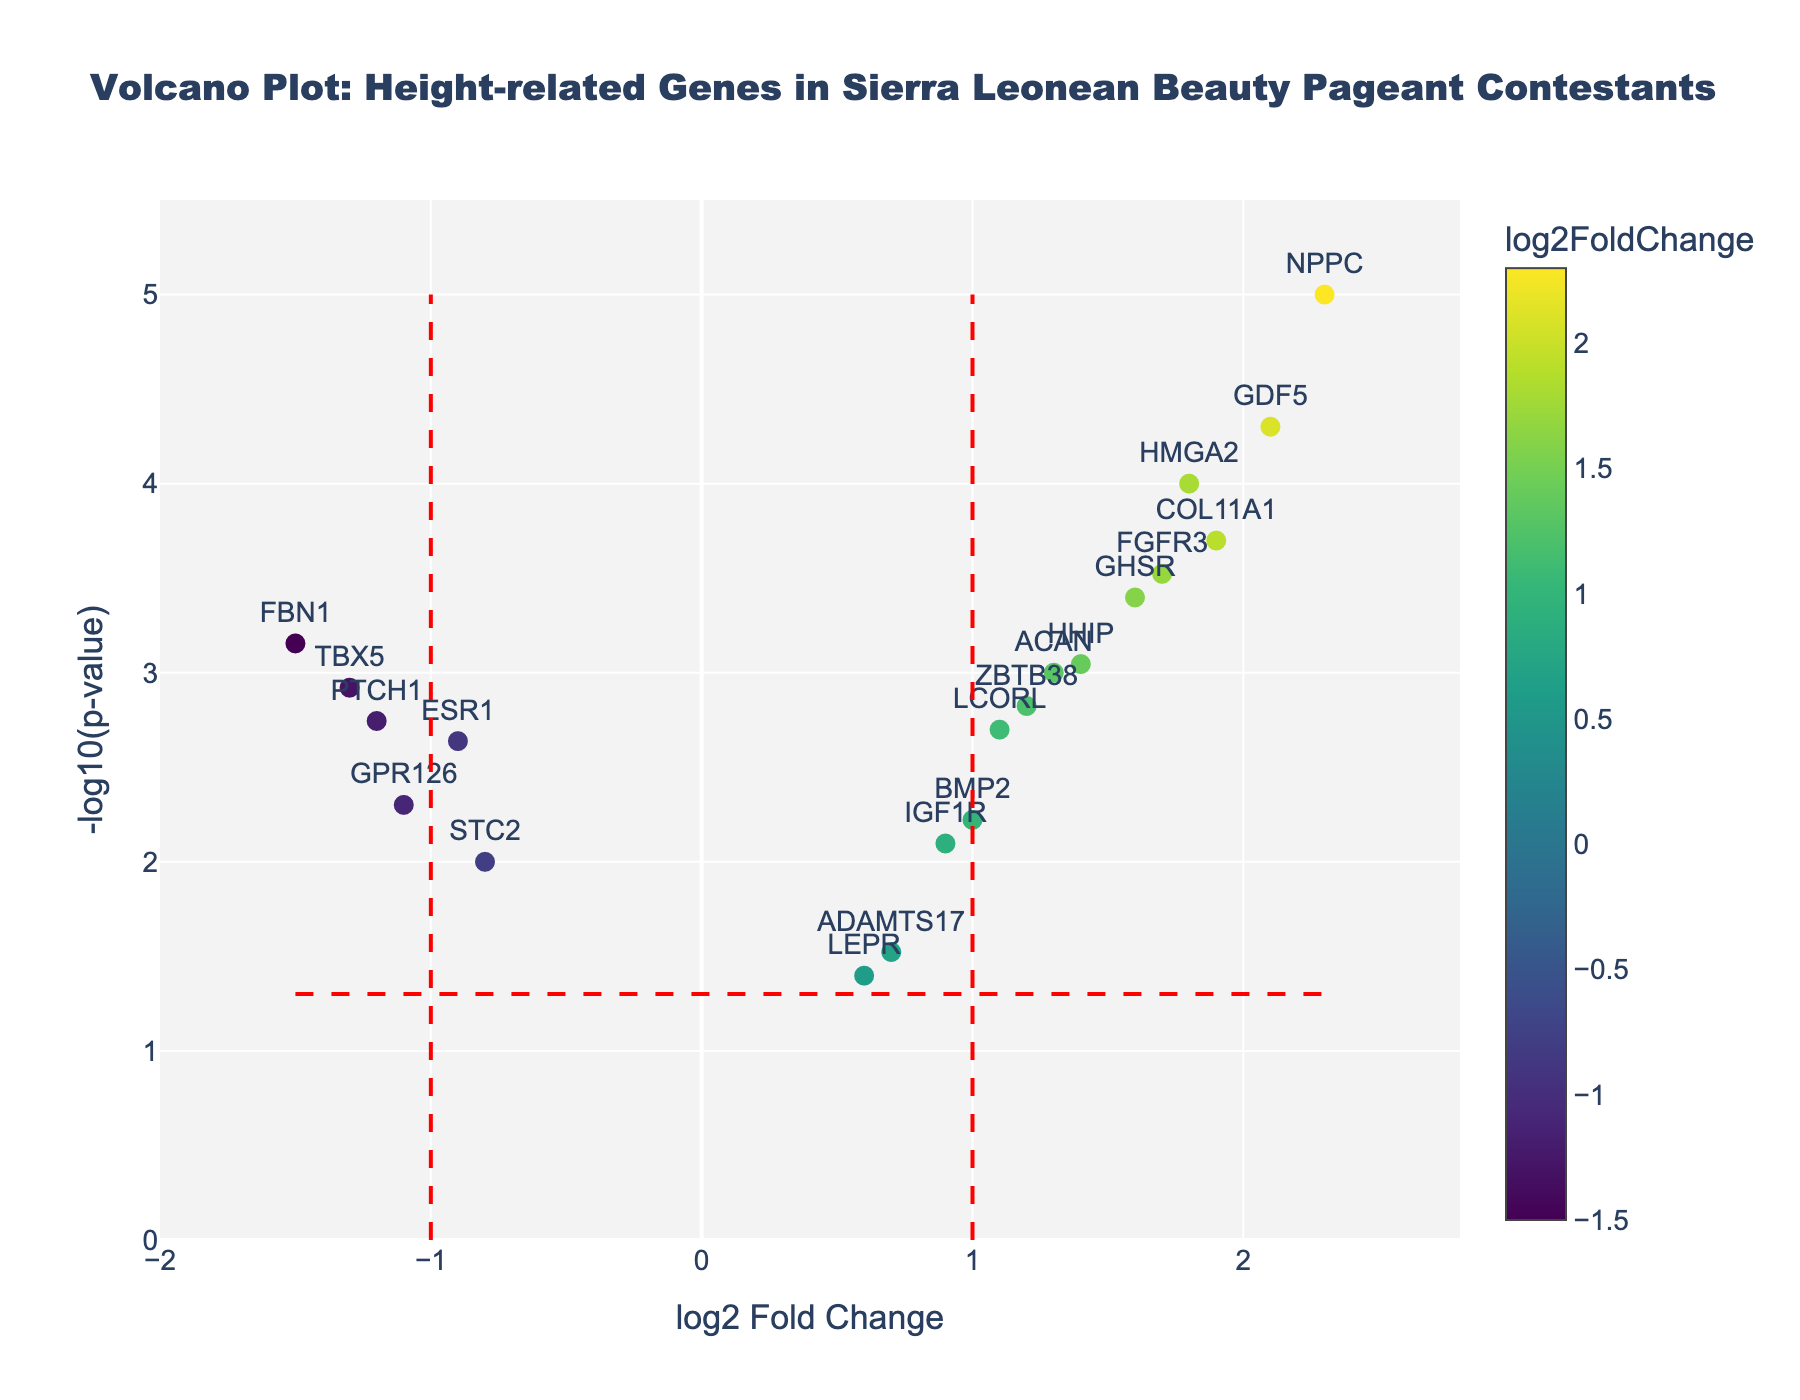What is the title of the plot? The title of the plot can be found at the top center in larger font size. It states what the plot is about.
Answer: Volcano Plot: Height-related Genes in Sierra Leonean Beauty Pageant Contestants What does the x-axis represent? The x-axis label indicates what the horizontal axis measures, found below the axis itself.
Answer: log2 Fold Change How many genes have a log2 Fold Change greater than 1? Examine the scatter plot and count the number of data points (genes) with x-values greater than 1. These represent log2 fold changes greater than 1.
Answer: 7 Which gene has the highest -log10(p-value)? Identify the gene corresponding to the data point at the topmost position on the y-axis (-log10(p-value) axis).
Answer: NPPC How many genes have a p-value lower than 0.05? A horizontal reference line is drawn at -log10(0.05). Count all data points above this line, indicating p-values below 0.05.
Answer: 14 Which gene shows the strongest positive association with height? Identify the gene at the rightmost end of the x-axis, indicating the highest positive log2 Fold Change.
Answer: NPPC What is the -log10(p-value) for the gene HMGA2? Locate the HMGA2 data point on the scatter plot, then read off the y-axis value.
Answer: 4 Which gene exhibits a significant but negative log2 Fold Change? Identify genes on the left side of the plot (negative log2 Fold Change) above the horizontal reference line (-log10(p-value) > 1.3).
Answer: ESR1, FBN1, GPR126, TBX5, PTCH1 How many genes have both log2 Fold Change between -1 and 1 and a p-value greater than 0.05? Locate genes within the log2 Fold Change range of -1 to 1 (center of x-axis) and below the horizontal reference line (-log10(p-value) < 1.3). Count these data points.
Answer: 2 What does a point below the horizontal reference line indicate about the corresponding gene's significance? Points below the horizontal reference line have a -log10(p-value) less than approximately 1.3, implying their p-value is greater than 0.05, indicating less statistical significance.
Answer: Less statistically significant (p-value > 0.05) 